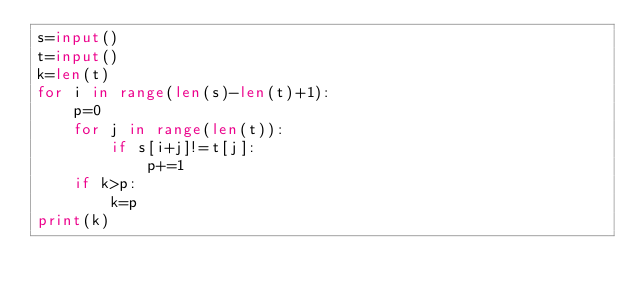<code> <loc_0><loc_0><loc_500><loc_500><_Python_>s=input()
t=input()
k=len(t)
for i in range(len(s)-len(t)+1):
    p=0
    for j in range(len(t)):
        if s[i+j]!=t[j]:
            p+=1
    if k>p:
        k=p
print(k)</code> 